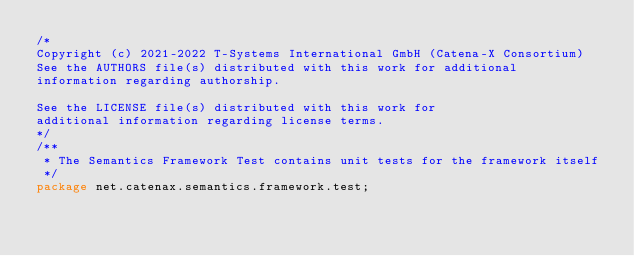<code> <loc_0><loc_0><loc_500><loc_500><_Java_>/*
Copyright (c) 2021-2022 T-Systems International GmbH (Catena-X Consortium)
See the AUTHORS file(s) distributed with this work for additional
information regarding authorship.

See the LICENSE file(s) distributed with this work for
additional information regarding license terms.
*/
/**
 * The Semantics Framework Test contains unit tests for the framework itself
 */
package net.catenax.semantics.framework.test;</code> 